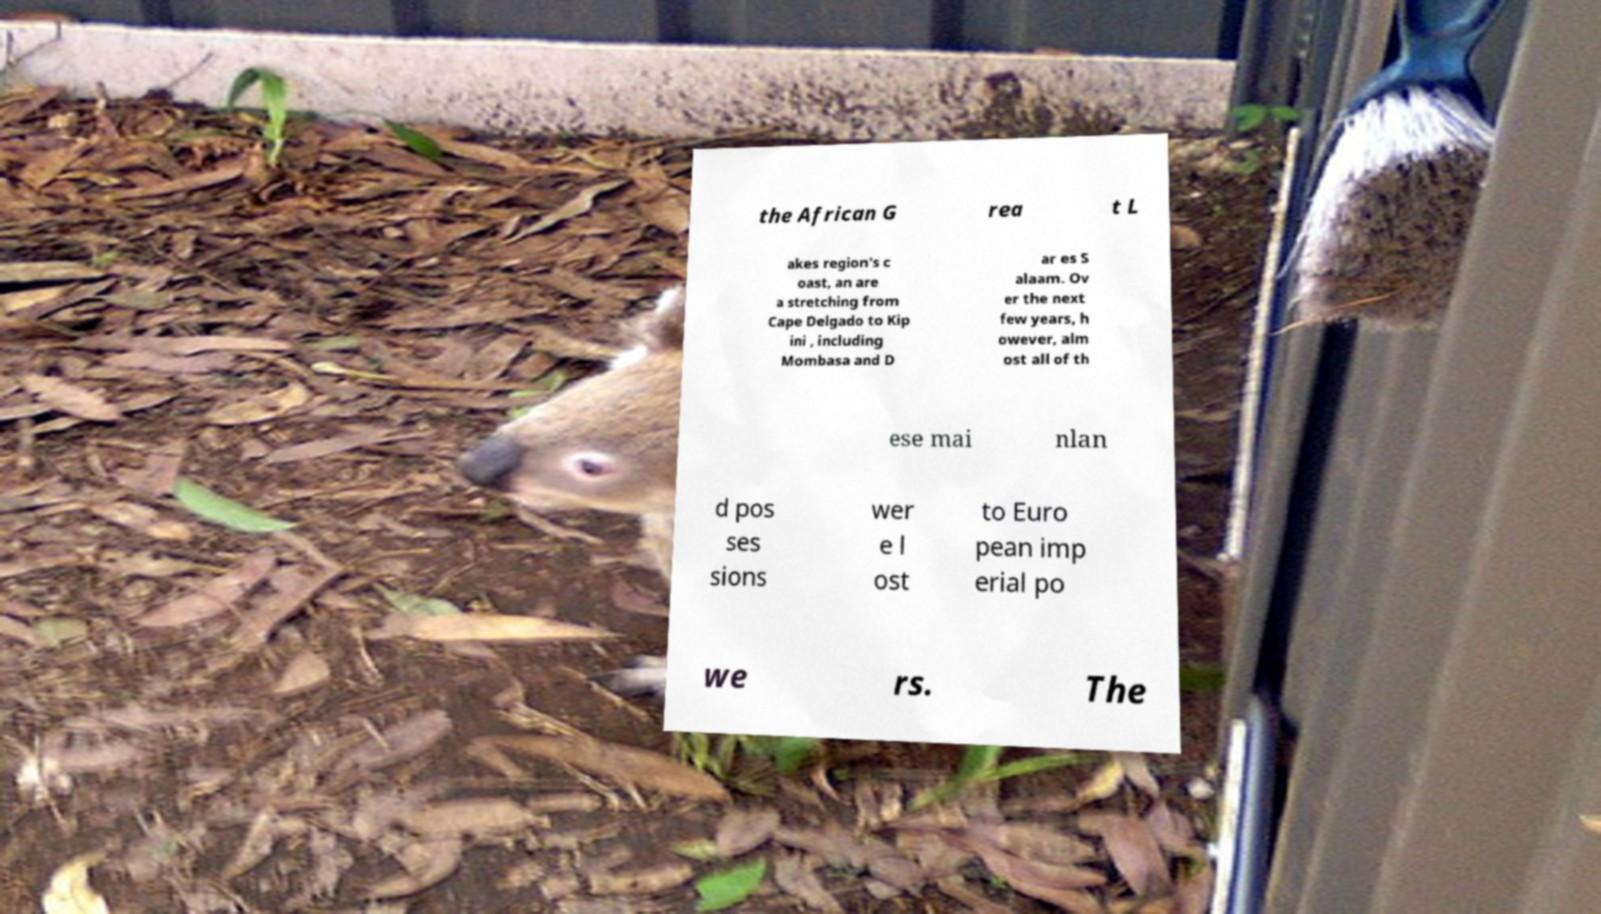Could you extract and type out the text from this image? the African G rea t L akes region's c oast, an are a stretching from Cape Delgado to Kip ini , including Mombasa and D ar es S alaam. Ov er the next few years, h owever, alm ost all of th ese mai nlan d pos ses sions wer e l ost to Euro pean imp erial po we rs. The 